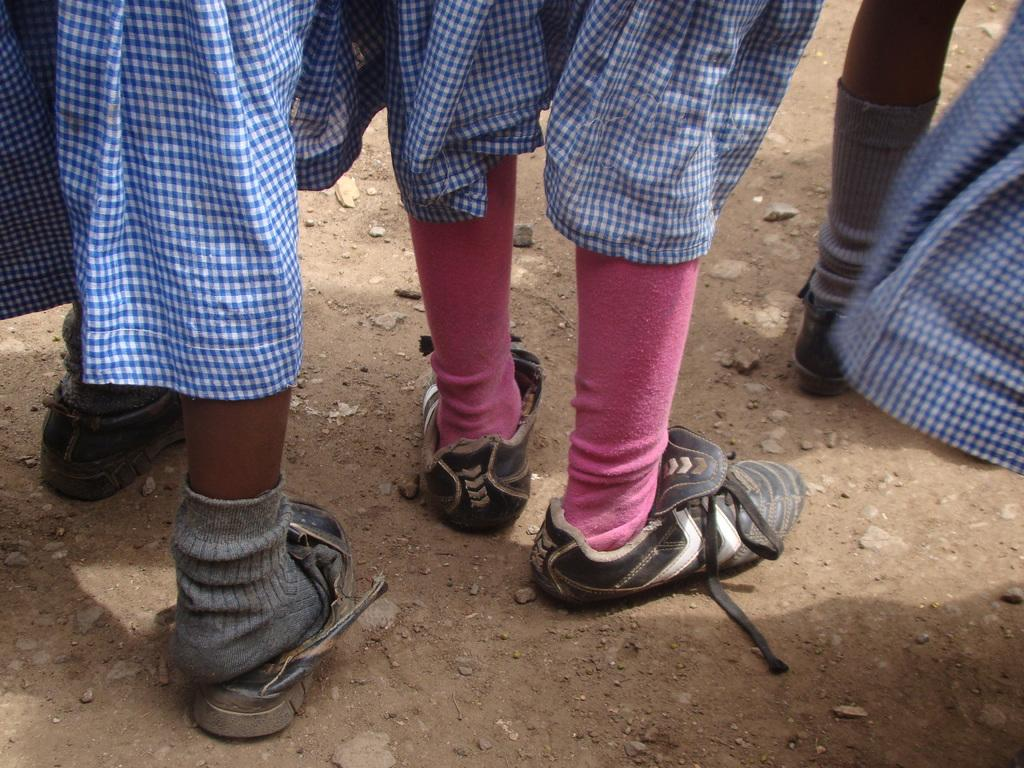What can be seen in the image in terms of human presence? There are people standing in the image. What part of their bodies is visible? Their legs are visible in the image. What type of footwear are the people wearing? The people are wearing shoes. What type of socks can be seen in the image? There are grey socks and a pair of pink socks visible in the image. What type of news can be seen being delivered by the zebra in the image? There is no zebra present in the image, and therefore no news being delivered by a zebra. 